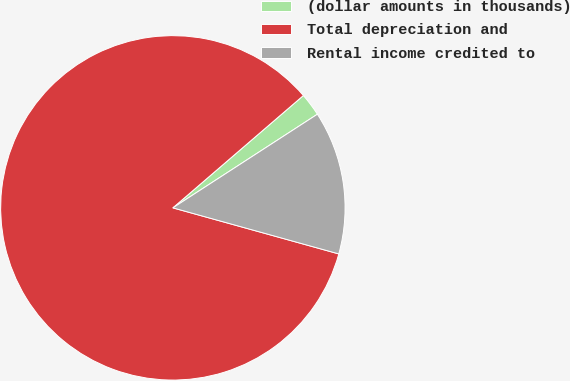Convert chart to OTSL. <chart><loc_0><loc_0><loc_500><loc_500><pie_chart><fcel>(dollar amounts in thousands)<fcel>Total depreciation and<fcel>Rental income credited to<nl><fcel>2.16%<fcel>84.38%<fcel>13.46%<nl></chart> 